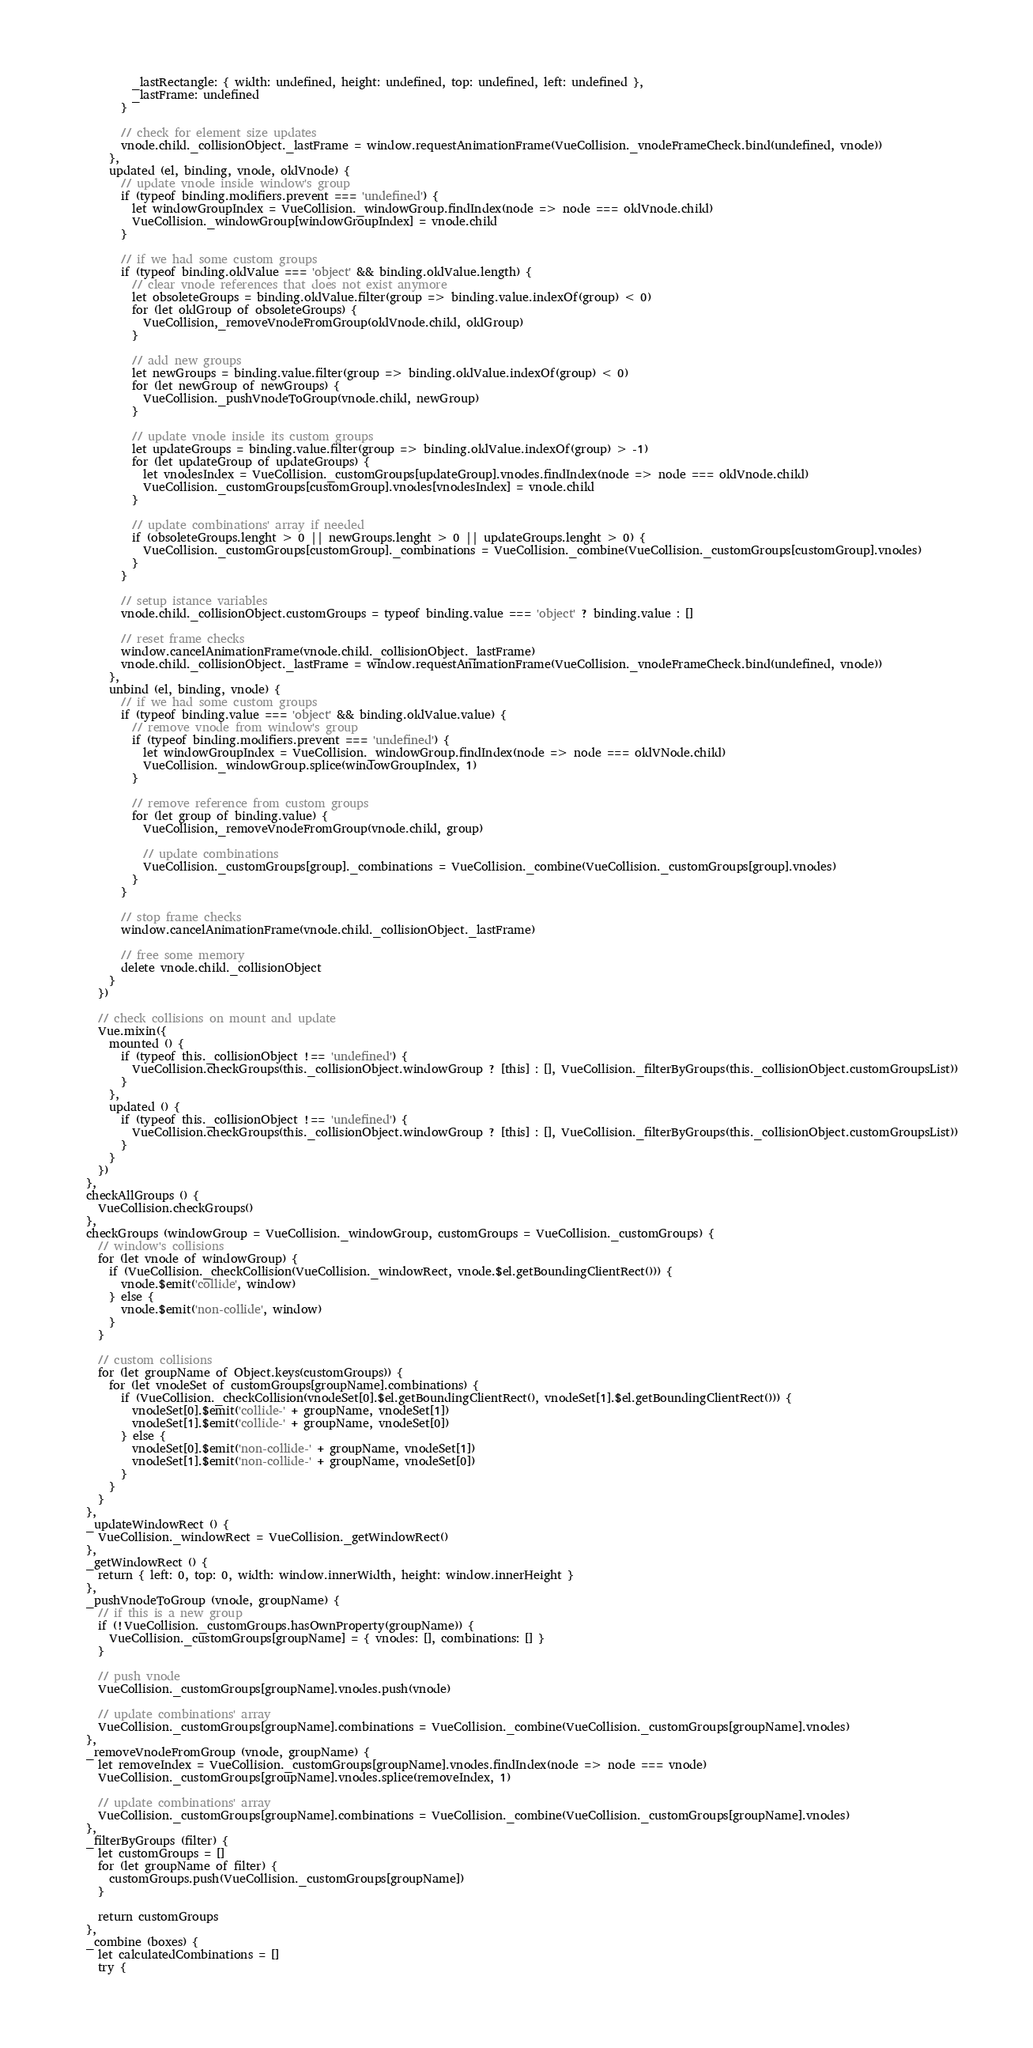<code> <loc_0><loc_0><loc_500><loc_500><_JavaScript_>          _lastRectangle: { width: undefined, height: undefined, top: undefined, left: undefined },
          _lastFrame: undefined
        }

        // check for element size updates
        vnode.child._collisionObject._lastFrame = window.requestAnimationFrame(VueCollision._vnodeFrameCheck.bind(undefined, vnode))
      },
      updated (el, binding, vnode, oldVnode) {
        // update vnode inside window's group
        if (typeof binding.modifiers.prevent === 'undefined') {
          let windowGroupIndex = VueCollision._windowGroup.findIndex(node => node === oldVnode.child)
          VueCollision._windowGroup[windowGroupIndex] = vnode.child
        }

        // if we had some custom groups
        if (typeof binding.oldValue === 'object' && binding.oldValue.length) {
          // clear vnode references that does not exist anymore
          let obsoleteGroups = binding.oldValue.filter(group => binding.value.indexOf(group) < 0)
          for (let oldGroup of obsoleteGroups) {
            VueCollision,_removeVnodeFromGroup(oldVnode.child, oldGroup)
          }

          // add new groups
          let newGroups = binding.value.filter(group => binding.oldValue.indexOf(group) < 0)
          for (let newGroup of newGroups) {
            VueCollision._pushVnodeToGroup(vnode.child, newGroup)
          }

          // update vnode inside its custom groups
          let updateGroups = binding.value.filter(group => binding.oldValue.indexOf(group) > -1)
          for (let updateGroup of updateGroups) {
            let vnodesIndex = VueCollision._customGroups[updateGroup].vnodes.findIndex(node => node === oldVnode.child)
            VueCollision._customGroups[customGroup].vnodes[vnodesIndex] = vnode.child
          }

          // update combinations' array if needed
          if (obsoleteGroups.lenght > 0 || newGroups.lenght > 0 || updateGroups.lenght > 0) {
            VueCollision._customGroups[customGroup]._combinations = VueCollision._combine(VueCollision._customGroups[customGroup].vnodes)
          }
        }

        // setup istance variables
        vnode.child._collisionObject.customGroups = typeof binding.value === 'object' ? binding.value : []

        // reset frame checks
        window.cancelAnimationFrame(vnode.child._collisionObject._lastFrame)
        vnode.child._collisionObject._lastFrame = window.requestAnimationFrame(VueCollision._vnodeFrameCheck.bind(undefined, vnode))
      },
      unbind (el, binding, vnode) {
        // if we had some custom groups
        if (typeof binding.value === 'object' && binding.oldValue.value) {
          // remove vnode from window's group
          if (typeof binding.modifiers.prevent === 'undefined') {
            let windowGroupIndex = VueCollision._windowGroup.findIndex(node => node === oldVNode.child)
            VueCollision._windowGroup.splice(windowGroupIndex, 1)
          }

          // remove reference from custom groups
          for (let group of binding.value) {
            VueCollision,_removeVnodeFromGroup(vnode.child, group)

            // update combinations
            VueCollision._customGroups[group]._combinations = VueCollision._combine(VueCollision._customGroups[group].vnodes)
          }
        }

        // stop frame checks
        window.cancelAnimationFrame(vnode.child._collisionObject._lastFrame)

        // free some memory
        delete vnode.child._collisionObject
      }
    })

    // check collisions on mount and update
    Vue.mixin({
      mounted () {
        if (typeof this._collisionObject !== 'undefined') {
          VueCollision.checkGroups(this._collisionObject.windowGroup ? [this] : [], VueCollision._filterByGroups(this._collisionObject.customGroupsList))
        }
      },
      updated () {
        if (typeof this._collisionObject !== 'undefined') {
          VueCollision.checkGroups(this._collisionObject.windowGroup ? [this] : [], VueCollision._filterByGroups(this._collisionObject.customGroupsList))
        }
      }
    })
  },
  checkAllGroups () {
    VueCollision.checkGroups()
  },
  checkGroups (windowGroup = VueCollision._windowGroup, customGroups = VueCollision._customGroups) {
    // window's collisions
    for (let vnode of windowGroup) {
      if (VueCollision._checkCollision(VueCollision._windowRect, vnode.$el.getBoundingClientRect())) {
        vnode.$emit('collide', window)
      } else {
        vnode.$emit('non-collide', window)
      }
    }

    // custom collisions
    for (let groupName of Object.keys(customGroups)) {
      for (let vnodeSet of customGroups[groupName].combinations) {
        if (VueCollision._checkCollision(vnodeSet[0].$el.getBoundingClientRect(), vnodeSet[1].$el.getBoundingClientRect())) {
          vnodeSet[0].$emit('collide-' + groupName, vnodeSet[1])
          vnodeSet[1].$emit('collide-' + groupName, vnodeSet[0])
        } else {
          vnodeSet[0].$emit('non-collide-' + groupName, vnodeSet[1])
          vnodeSet[1].$emit('non-collide-' + groupName, vnodeSet[0])
        }
      }
    }
  },
  _updateWindowRect () {
    VueCollision._windowRect = VueCollision._getWindowRect()
  },
  _getWindowRect () {
    return { left: 0, top: 0, width: window.innerWidth, height: window.innerHeight }
  },
  _pushVnodeToGroup (vnode, groupName) {
    // if this is a new group
    if (!VueCollision._customGroups.hasOwnProperty(groupName)) {
      VueCollision._customGroups[groupName] = { vnodes: [], combinations: [] }
    }

    // push vnode
    VueCollision._customGroups[groupName].vnodes.push(vnode)

    // update combinations' array
    VueCollision._customGroups[groupName].combinations = VueCollision._combine(VueCollision._customGroups[groupName].vnodes)
  },
  _removeVnodeFromGroup (vnode, groupName) {
    let removeIndex = VueCollision._customGroups[groupName].vnodes.findIndex(node => node === vnode)
    VueCollision._customGroups[groupName].vnodes.splice(removeIndex, 1)

    // update combinations' array
    VueCollision._customGroups[groupName].combinations = VueCollision._combine(VueCollision._customGroups[groupName].vnodes)
  },
  _filterByGroups (filter) {
    let customGroups = []
    for (let groupName of filter) {
      customGroups.push(VueCollision._customGroups[groupName])
    }

    return customGroups
  },
  _combine (boxes) {
    let calculatedCombinations = []
    try {</code> 